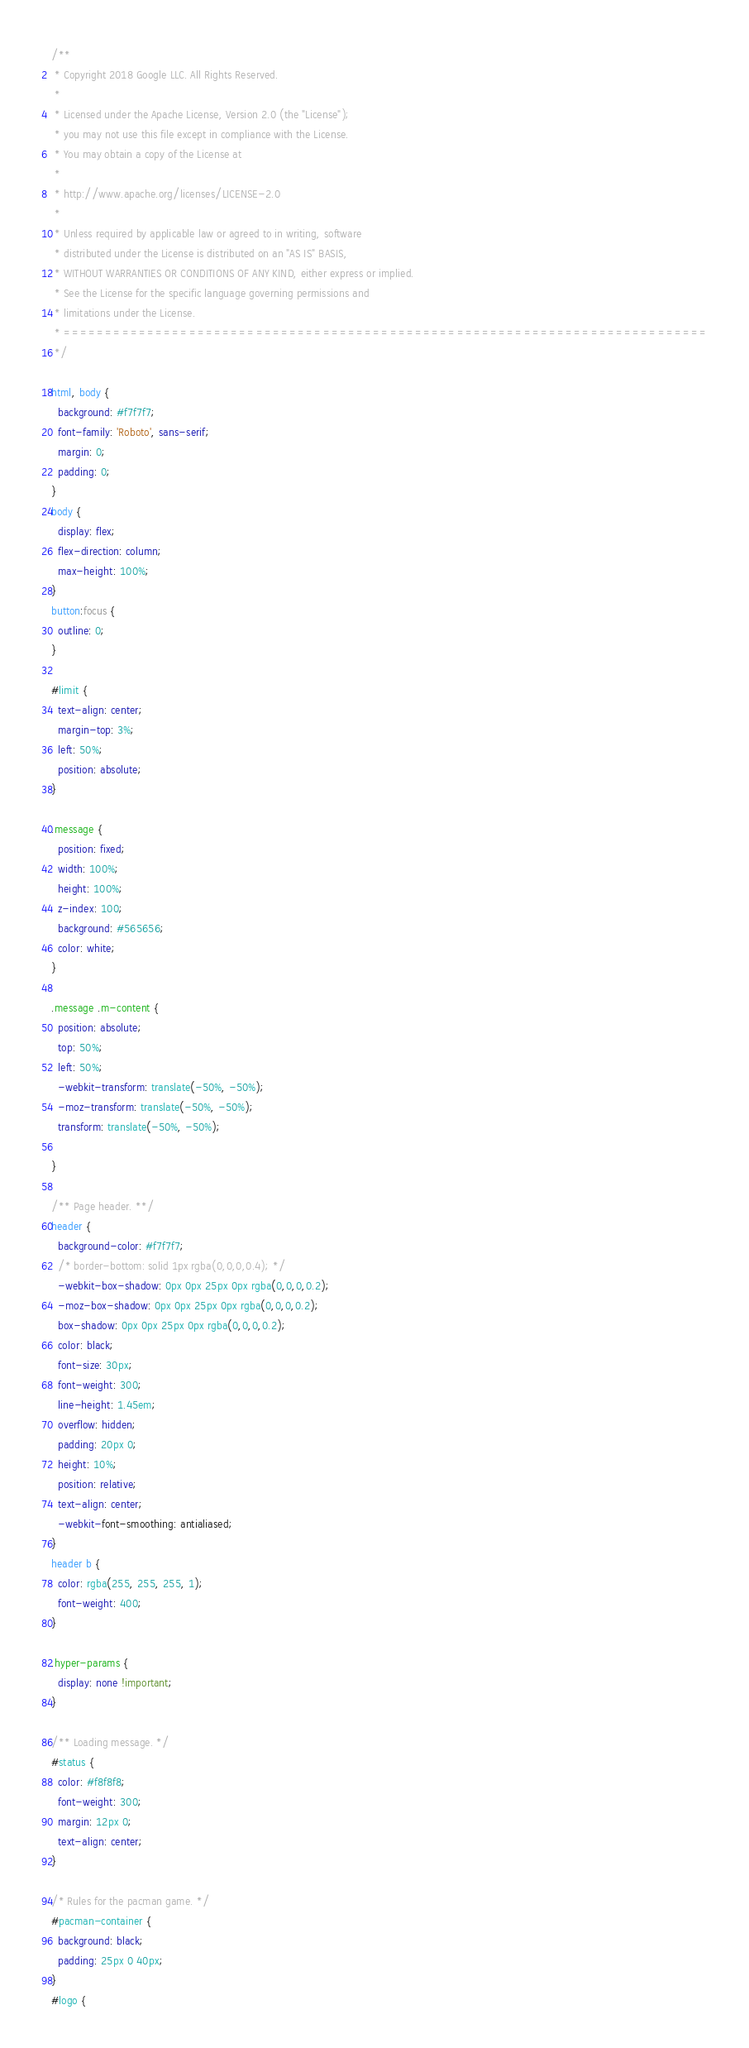<code> <loc_0><loc_0><loc_500><loc_500><_CSS_>/**
 * Copyright 2018 Google LLC. All Rights Reserved.
 *
 * Licensed under the Apache License, Version 2.0 (the "License");
 * you may not use this file except in compliance with the License.
 * You may obtain a copy of the License at
 *
 * http://www.apache.org/licenses/LICENSE-2.0
 *
 * Unless required by applicable law or agreed to in writing, software
 * distributed under the License is distributed on an "AS IS" BASIS,
 * WITHOUT WARRANTIES OR CONDITIONS OF ANY KIND, either express or implied.
 * See the License for the specific language governing permissions and
 * limitations under the License.
 * =============================================================================
 */

html, body {
  background: #f7f7f7;
  font-family: 'Roboto', sans-serif;
  margin: 0;
  padding: 0;
}
body {
  display: flex;
  flex-direction: column;
  max-height: 100%;
}
button:focus {
  outline: 0;
}

#limit {
  text-align: center;
  margin-top: 3%;
  left: 50%;
  position: absolute;
}

.message {
  position: fixed;
  width: 100%;
  height: 100%;
  z-index: 100;
  background: #565656;
  color: white;
}

.message .m-content {
  position: absolute;
  top: 50%;
  left: 50%;
  -webkit-transform: translate(-50%, -50%);
  -moz-transform: translate(-50%, -50%);
  transform: translate(-50%, -50%);

}

/** Page header. **/
header {
  background-color: #f7f7f7;
  /* border-bottom: solid 1px rgba(0,0,0,0.4); */
  -webkit-box-shadow: 0px 0px 25px 0px rgba(0,0,0,0.2);
  -moz-box-shadow: 0px 0px 25px 0px rgba(0,0,0,0.2);
  box-shadow: 0px 0px 25px 0px rgba(0,0,0,0.2);
  color: black;
  font-size: 30px;
  font-weight: 300;
  line-height: 1.45em;
  overflow: hidden;
  padding: 20px 0;
  height: 10%;
  position: relative;
  text-align: center;
  -webkit-font-smoothing: antialiased;
}
header b {
  color: rgba(255, 255, 255, 1);
  font-weight: 400;
}

.hyper-params {
  display: none !important;
}

/** Loading message. */
#status {
  color: #f8f8f8;
  font-weight: 300;
  margin: 12px 0;
  text-align: center;
}

/* Rules for the pacman game. */
#pacman-container {
  background: black;
  padding: 25px 0 40px;
}
#logo {</code> 